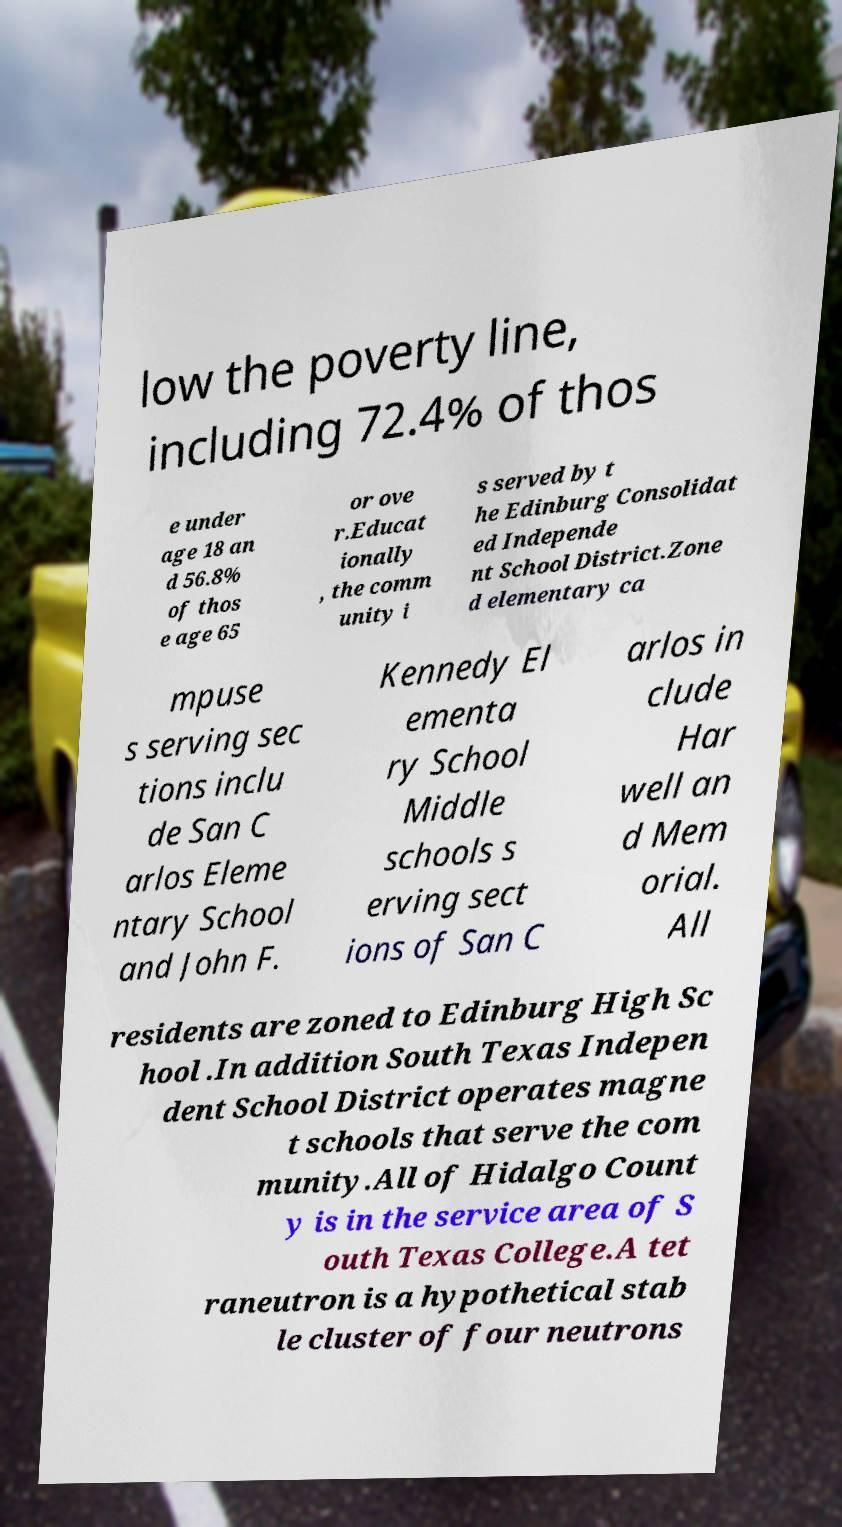For documentation purposes, I need the text within this image transcribed. Could you provide that? low the poverty line, including 72.4% of thos e under age 18 an d 56.8% of thos e age 65 or ove r.Educat ionally , the comm unity i s served by t he Edinburg Consolidat ed Independe nt School District.Zone d elementary ca mpuse s serving sec tions inclu de San C arlos Eleme ntary School and John F. Kennedy El ementa ry School Middle schools s erving sect ions of San C arlos in clude Har well an d Mem orial. All residents are zoned to Edinburg High Sc hool .In addition South Texas Indepen dent School District operates magne t schools that serve the com munity.All of Hidalgo Count y is in the service area of S outh Texas College.A tet raneutron is a hypothetical stab le cluster of four neutrons 